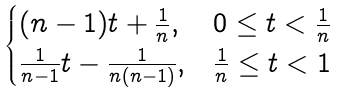<formula> <loc_0><loc_0><loc_500><loc_500>\begin{cases} ( n - 1 ) t + \frac { 1 } { n } , & 0 \leq t < \frac { 1 } { n } \\ \frac { 1 } { n - 1 } t - \frac { 1 } { n ( n - 1 ) } , & \frac { 1 } { n } \leq t < 1 \\ \end{cases}</formula> 